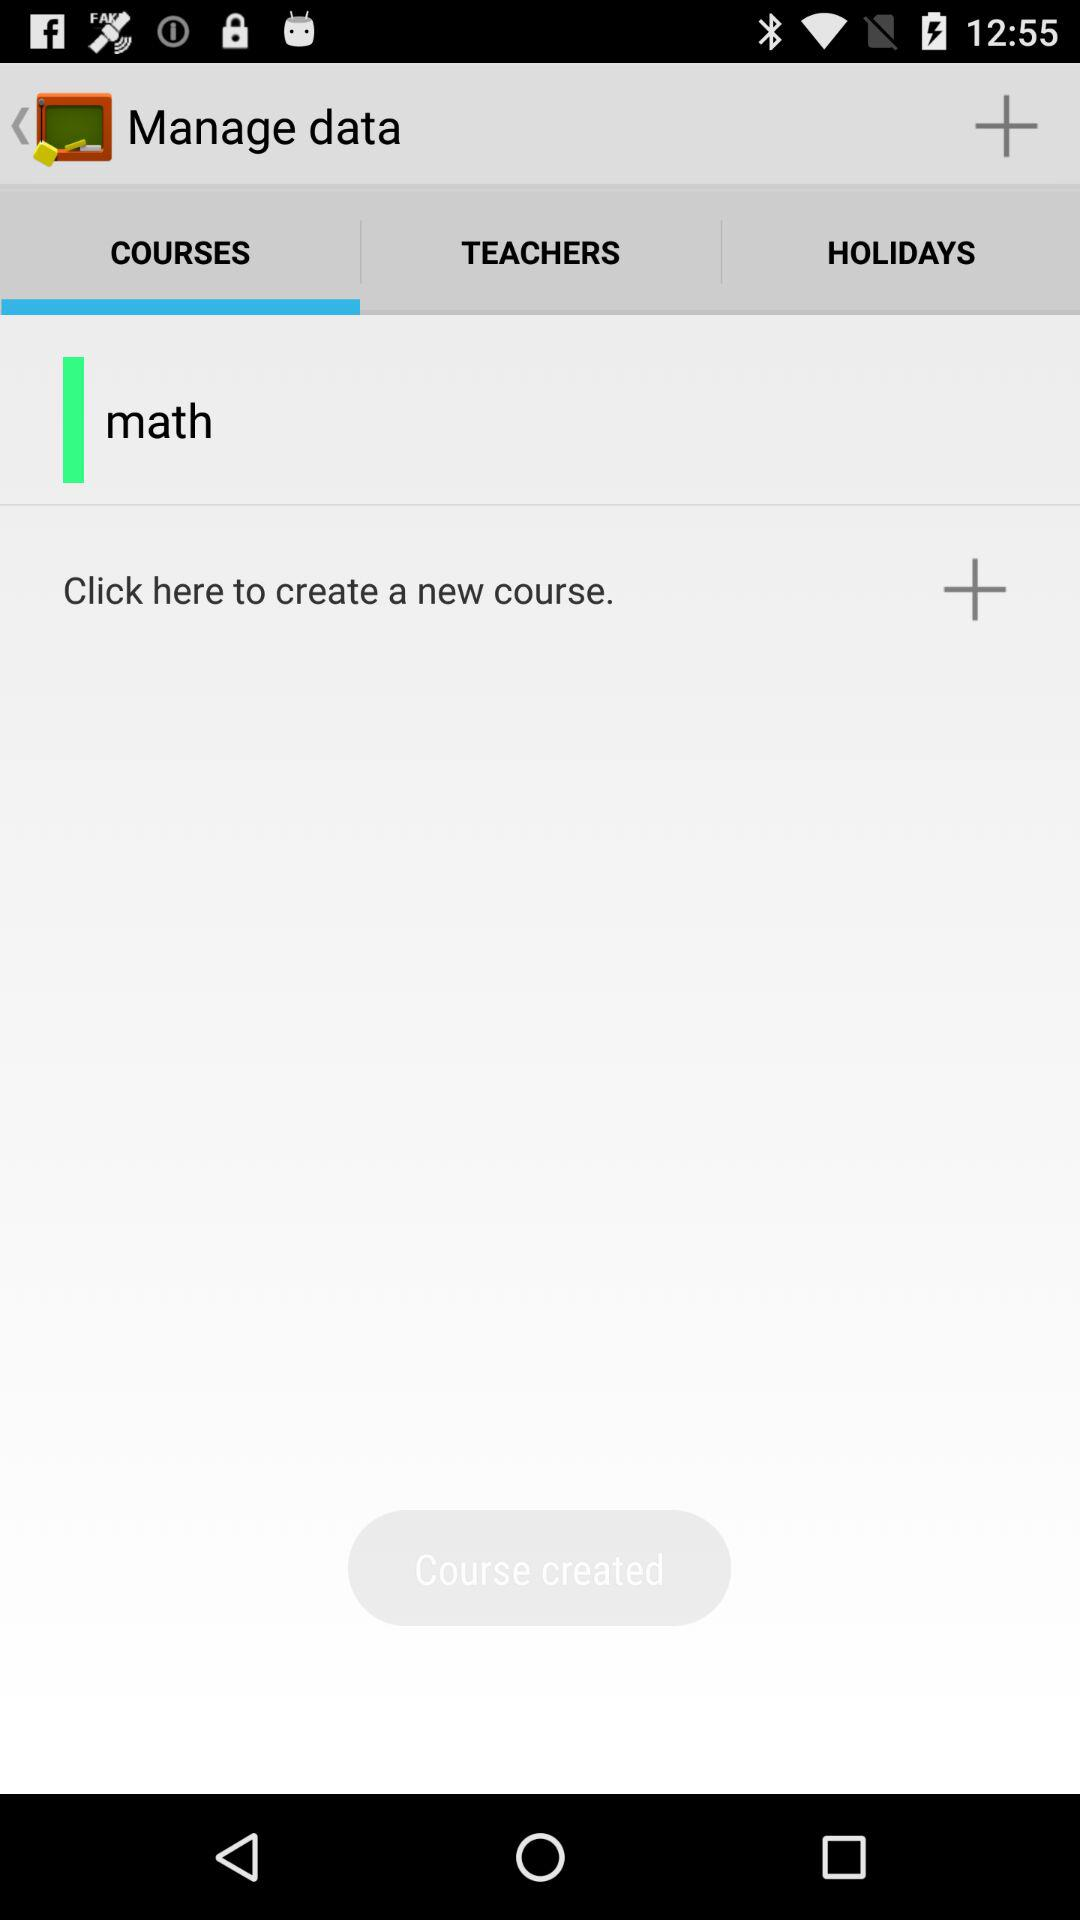Which tab of the application are we on? You are on the "COURSES" tab. 